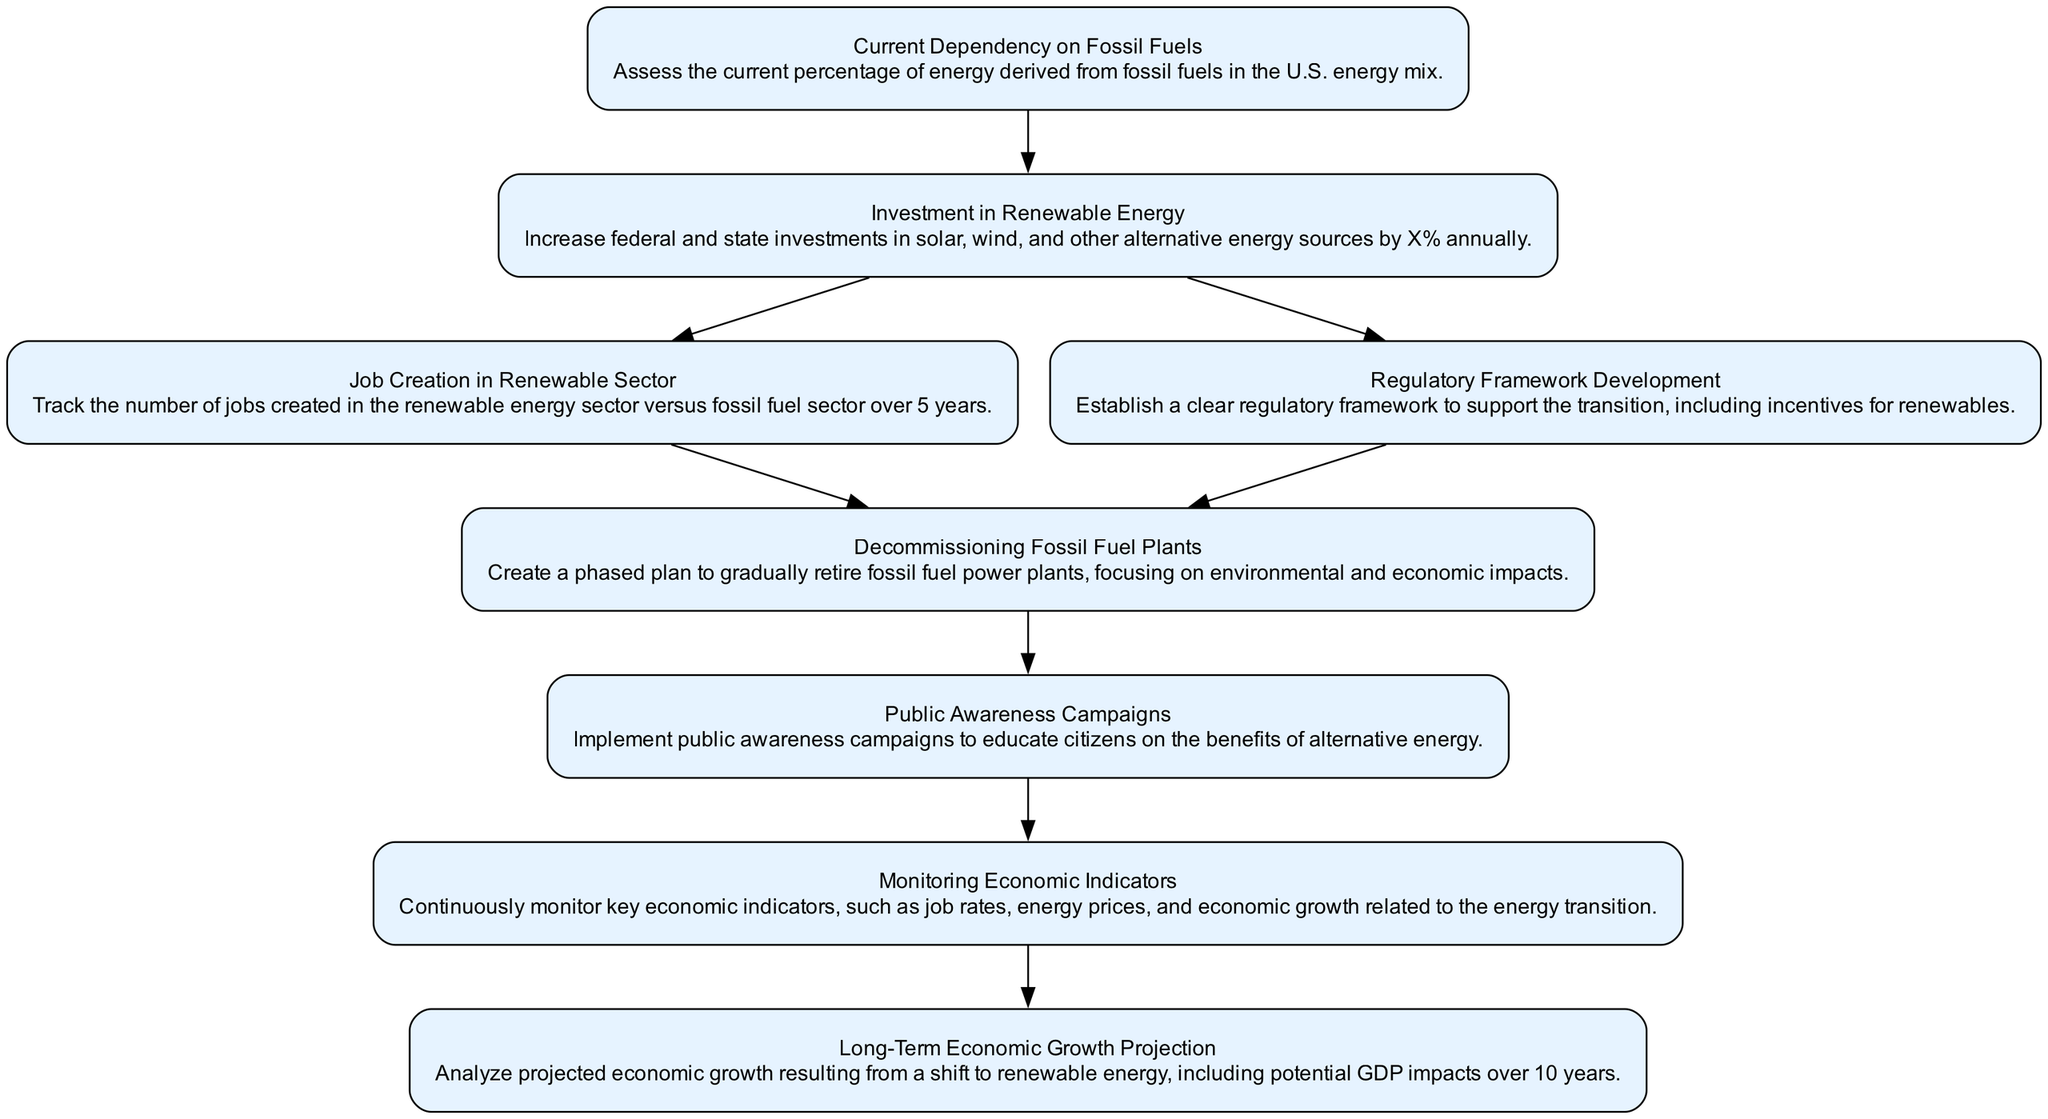What is the initial dependency percentage on fossil fuels? The first node indicates this is "Current Dependency on Fossil Fuels," which assesses the percentage of energy derived from fossil fuels in the U.S. energy mix, but does not provide a specific number here. Further details might be found in underlying data or in the context of the discussion.
Answer: Current Dependency on Fossil Fuels What is the first action step related to the transition? The diagram shows the arrow leading from the "Current Dependency on Fossil Fuels" node to the "Investment in Renewable Energy" node, indicating that increasing investments is the first action step taken towards transition.
Answer: Investment in Renewable Energy How many job sectors are tracked over five years? Based on the flow of the diagram, there is a focus on tracking the "Job Creation in Renewable Sector" versus the fossil fuel sector, which means two sectors are being compared over the span of five years.
Answer: Two sectors What is the connection between job creation and regulatory framework? The flow from "Investment in Renewable Energy" to "Job Creation in Renewable Sector" and "Regulatory Framework Development" suggests that both job creation and a regulatory framework are influenced by investments in renewable energy, showing their interrelation in the transition.
Answer: Investment in Renewable Energy What is monitored continuously as part of the transition? The diagram connects from "Public Awareness Campaigns" to "Monitoring Economic Indicators," indicating that continuous monitoring of key economic indicators is integral to evaluate the impact of the transition.
Answer: Economic indicators How many nodes are there in total in the diagram? Upon counting all the individual elements listed in the data provided, it can be seen that there are a total of eight nodes in the diagram that represent various stages and actions in the transition.
Answer: Eight nodes What is the final analysis conducted in this flow chart? The last node in the flow chart leads to "Long-Term Economic Growth Projection," which means that the final analysis involves analyzing the projected economic growth and potential GDP impacts from the shift to renewable energy.
Answer: Long-Term Economic Growth Projection Which node focuses on the decommissioning of fossil fuel plants? The diagram indicates a specific node titled "Decommissioning Fossil Fuel Plants," which is about creating a phased plan to retire these plants, showing a direct focus on this action within the transition process.
Answer: Decommissioning Fossil Fuel Plants 